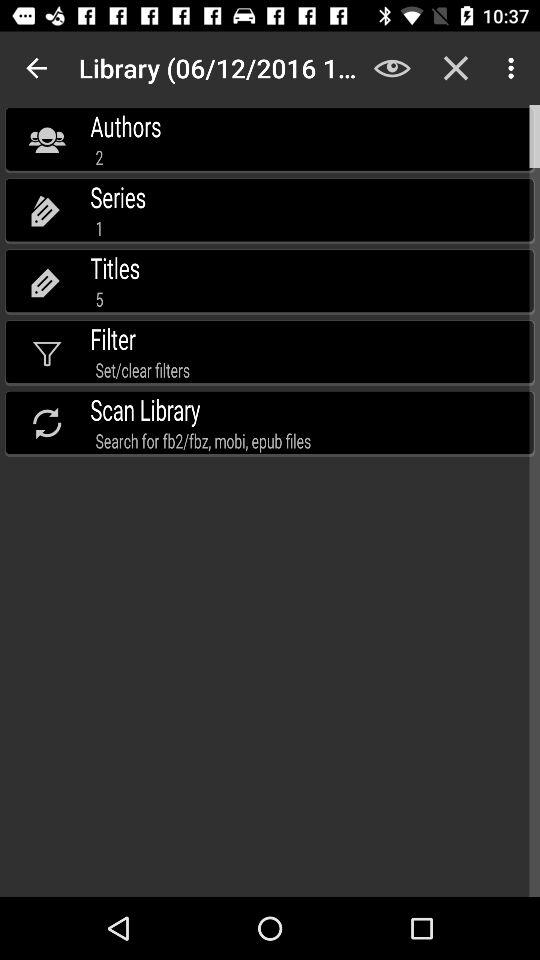What is the total number of authors? The total number of authors is 2. 